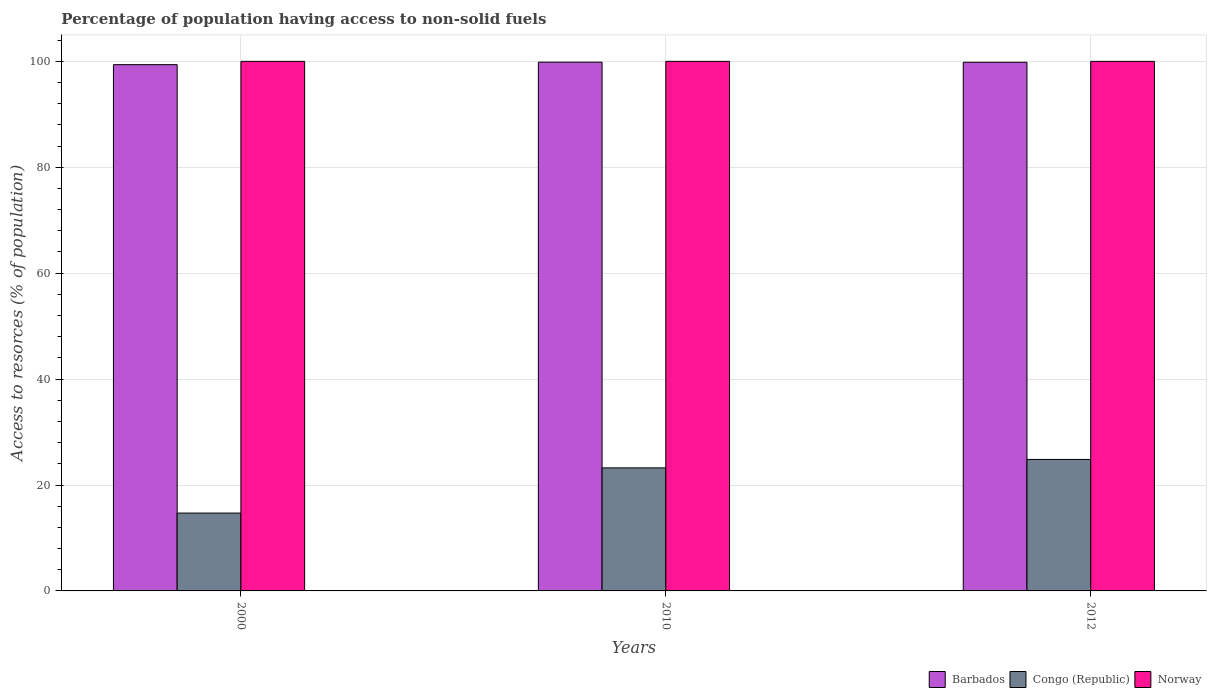How many different coloured bars are there?
Offer a terse response. 3. Are the number of bars on each tick of the X-axis equal?
Offer a very short reply. Yes. How many bars are there on the 3rd tick from the left?
Ensure brevity in your answer.  3. How many bars are there on the 2nd tick from the right?
Offer a terse response. 3. In how many cases, is the number of bars for a given year not equal to the number of legend labels?
Ensure brevity in your answer.  0. What is the percentage of population having access to non-solid fuels in Congo (Republic) in 2000?
Your response must be concise. 14.7. Across all years, what is the maximum percentage of population having access to non-solid fuels in Norway?
Offer a terse response. 100. Across all years, what is the minimum percentage of population having access to non-solid fuels in Norway?
Your answer should be compact. 100. In which year was the percentage of population having access to non-solid fuels in Congo (Republic) minimum?
Provide a succinct answer. 2000. What is the total percentage of population having access to non-solid fuels in Norway in the graph?
Offer a very short reply. 300. What is the difference between the percentage of population having access to non-solid fuels in Barbados in 2010 and that in 2012?
Make the answer very short. 0.02. What is the difference between the percentage of population having access to non-solid fuels in Congo (Republic) in 2010 and the percentage of population having access to non-solid fuels in Barbados in 2012?
Ensure brevity in your answer.  -76.59. What is the average percentage of population having access to non-solid fuels in Congo (Republic) per year?
Offer a very short reply. 20.92. In the year 2012, what is the difference between the percentage of population having access to non-solid fuels in Barbados and percentage of population having access to non-solid fuels in Congo (Republic)?
Offer a very short reply. 75. What is the difference between the highest and the second highest percentage of population having access to non-solid fuels in Norway?
Offer a very short reply. 0. What is the difference between the highest and the lowest percentage of population having access to non-solid fuels in Barbados?
Your answer should be compact. 0.47. In how many years, is the percentage of population having access to non-solid fuels in Congo (Republic) greater than the average percentage of population having access to non-solid fuels in Congo (Republic) taken over all years?
Provide a short and direct response. 2. Is the sum of the percentage of population having access to non-solid fuels in Barbados in 2010 and 2012 greater than the maximum percentage of population having access to non-solid fuels in Norway across all years?
Give a very brief answer. Yes. What does the 1st bar from the left in 2000 represents?
Provide a succinct answer. Barbados. What does the 3rd bar from the right in 2000 represents?
Your response must be concise. Barbados. Is it the case that in every year, the sum of the percentage of population having access to non-solid fuels in Congo (Republic) and percentage of population having access to non-solid fuels in Norway is greater than the percentage of population having access to non-solid fuels in Barbados?
Give a very brief answer. Yes. How many bars are there?
Provide a short and direct response. 9. How many years are there in the graph?
Provide a short and direct response. 3. What is the difference between two consecutive major ticks on the Y-axis?
Offer a very short reply. 20. Does the graph contain any zero values?
Provide a short and direct response. No. Does the graph contain grids?
Provide a succinct answer. Yes. What is the title of the graph?
Your answer should be very brief. Percentage of population having access to non-solid fuels. Does "Honduras" appear as one of the legend labels in the graph?
Your response must be concise. No. What is the label or title of the X-axis?
Offer a terse response. Years. What is the label or title of the Y-axis?
Offer a terse response. Access to resorces (% of population). What is the Access to resorces (% of population) of Barbados in 2000?
Keep it short and to the point. 99.38. What is the Access to resorces (% of population) in Congo (Republic) in 2000?
Offer a terse response. 14.7. What is the Access to resorces (% of population) in Barbados in 2010?
Your response must be concise. 99.85. What is the Access to resorces (% of population) in Congo (Republic) in 2010?
Keep it short and to the point. 23.23. What is the Access to resorces (% of population) of Barbados in 2012?
Give a very brief answer. 99.83. What is the Access to resorces (% of population) in Congo (Republic) in 2012?
Offer a terse response. 24.83. Across all years, what is the maximum Access to resorces (% of population) of Barbados?
Provide a succinct answer. 99.85. Across all years, what is the maximum Access to resorces (% of population) of Congo (Republic)?
Your answer should be compact. 24.83. Across all years, what is the maximum Access to resorces (% of population) of Norway?
Make the answer very short. 100. Across all years, what is the minimum Access to resorces (% of population) of Barbados?
Your response must be concise. 99.38. Across all years, what is the minimum Access to resorces (% of population) of Congo (Republic)?
Give a very brief answer. 14.7. What is the total Access to resorces (% of population) of Barbados in the graph?
Your response must be concise. 299.05. What is the total Access to resorces (% of population) of Congo (Republic) in the graph?
Your response must be concise. 62.76. What is the total Access to resorces (% of population) of Norway in the graph?
Give a very brief answer. 300. What is the difference between the Access to resorces (% of population) in Barbados in 2000 and that in 2010?
Provide a short and direct response. -0.47. What is the difference between the Access to resorces (% of population) in Congo (Republic) in 2000 and that in 2010?
Make the answer very short. -8.53. What is the difference between the Access to resorces (% of population) of Barbados in 2000 and that in 2012?
Offer a very short reply. -0.45. What is the difference between the Access to resorces (% of population) in Congo (Republic) in 2000 and that in 2012?
Ensure brevity in your answer.  -10.13. What is the difference between the Access to resorces (% of population) in Norway in 2000 and that in 2012?
Offer a very short reply. 0. What is the difference between the Access to resorces (% of population) of Barbados in 2010 and that in 2012?
Provide a short and direct response. 0.02. What is the difference between the Access to resorces (% of population) of Congo (Republic) in 2010 and that in 2012?
Your response must be concise. -1.59. What is the difference between the Access to resorces (% of population) of Barbados in 2000 and the Access to resorces (% of population) of Congo (Republic) in 2010?
Your response must be concise. 76.15. What is the difference between the Access to resorces (% of population) of Barbados in 2000 and the Access to resorces (% of population) of Norway in 2010?
Make the answer very short. -0.62. What is the difference between the Access to resorces (% of population) of Congo (Republic) in 2000 and the Access to resorces (% of population) of Norway in 2010?
Your answer should be very brief. -85.3. What is the difference between the Access to resorces (% of population) of Barbados in 2000 and the Access to resorces (% of population) of Congo (Republic) in 2012?
Your answer should be compact. 74.55. What is the difference between the Access to resorces (% of population) in Barbados in 2000 and the Access to resorces (% of population) in Norway in 2012?
Your answer should be very brief. -0.62. What is the difference between the Access to resorces (% of population) in Congo (Republic) in 2000 and the Access to resorces (% of population) in Norway in 2012?
Keep it short and to the point. -85.3. What is the difference between the Access to resorces (% of population) in Barbados in 2010 and the Access to resorces (% of population) in Congo (Republic) in 2012?
Your response must be concise. 75.02. What is the difference between the Access to resorces (% of population) of Barbados in 2010 and the Access to resorces (% of population) of Norway in 2012?
Your answer should be compact. -0.15. What is the difference between the Access to resorces (% of population) of Congo (Republic) in 2010 and the Access to resorces (% of population) of Norway in 2012?
Your response must be concise. -76.77. What is the average Access to resorces (% of population) of Barbados per year?
Provide a succinct answer. 99.68. What is the average Access to resorces (% of population) of Congo (Republic) per year?
Provide a short and direct response. 20.92. What is the average Access to resorces (% of population) in Norway per year?
Your answer should be very brief. 100. In the year 2000, what is the difference between the Access to resorces (% of population) of Barbados and Access to resorces (% of population) of Congo (Republic)?
Provide a succinct answer. 84.68. In the year 2000, what is the difference between the Access to resorces (% of population) in Barbados and Access to resorces (% of population) in Norway?
Give a very brief answer. -0.62. In the year 2000, what is the difference between the Access to resorces (% of population) in Congo (Republic) and Access to resorces (% of population) in Norway?
Your answer should be very brief. -85.3. In the year 2010, what is the difference between the Access to resorces (% of population) of Barbados and Access to resorces (% of population) of Congo (Republic)?
Give a very brief answer. 76.61. In the year 2010, what is the difference between the Access to resorces (% of population) in Barbados and Access to resorces (% of population) in Norway?
Your answer should be compact. -0.15. In the year 2010, what is the difference between the Access to resorces (% of population) of Congo (Republic) and Access to resorces (% of population) of Norway?
Ensure brevity in your answer.  -76.77. In the year 2012, what is the difference between the Access to resorces (% of population) of Barbados and Access to resorces (% of population) of Congo (Republic)?
Keep it short and to the point. 75. In the year 2012, what is the difference between the Access to resorces (% of population) in Barbados and Access to resorces (% of population) in Norway?
Make the answer very short. -0.17. In the year 2012, what is the difference between the Access to resorces (% of population) in Congo (Republic) and Access to resorces (% of population) in Norway?
Make the answer very short. -75.17. What is the ratio of the Access to resorces (% of population) in Congo (Republic) in 2000 to that in 2010?
Keep it short and to the point. 0.63. What is the ratio of the Access to resorces (% of population) in Barbados in 2000 to that in 2012?
Keep it short and to the point. 1. What is the ratio of the Access to resorces (% of population) in Congo (Republic) in 2000 to that in 2012?
Ensure brevity in your answer.  0.59. What is the ratio of the Access to resorces (% of population) in Norway in 2000 to that in 2012?
Give a very brief answer. 1. What is the ratio of the Access to resorces (% of population) in Congo (Republic) in 2010 to that in 2012?
Make the answer very short. 0.94. What is the difference between the highest and the second highest Access to resorces (% of population) of Barbados?
Provide a short and direct response. 0.02. What is the difference between the highest and the second highest Access to resorces (% of population) in Congo (Republic)?
Provide a short and direct response. 1.59. What is the difference between the highest and the lowest Access to resorces (% of population) of Barbados?
Offer a very short reply. 0.47. What is the difference between the highest and the lowest Access to resorces (% of population) in Congo (Republic)?
Make the answer very short. 10.13. 